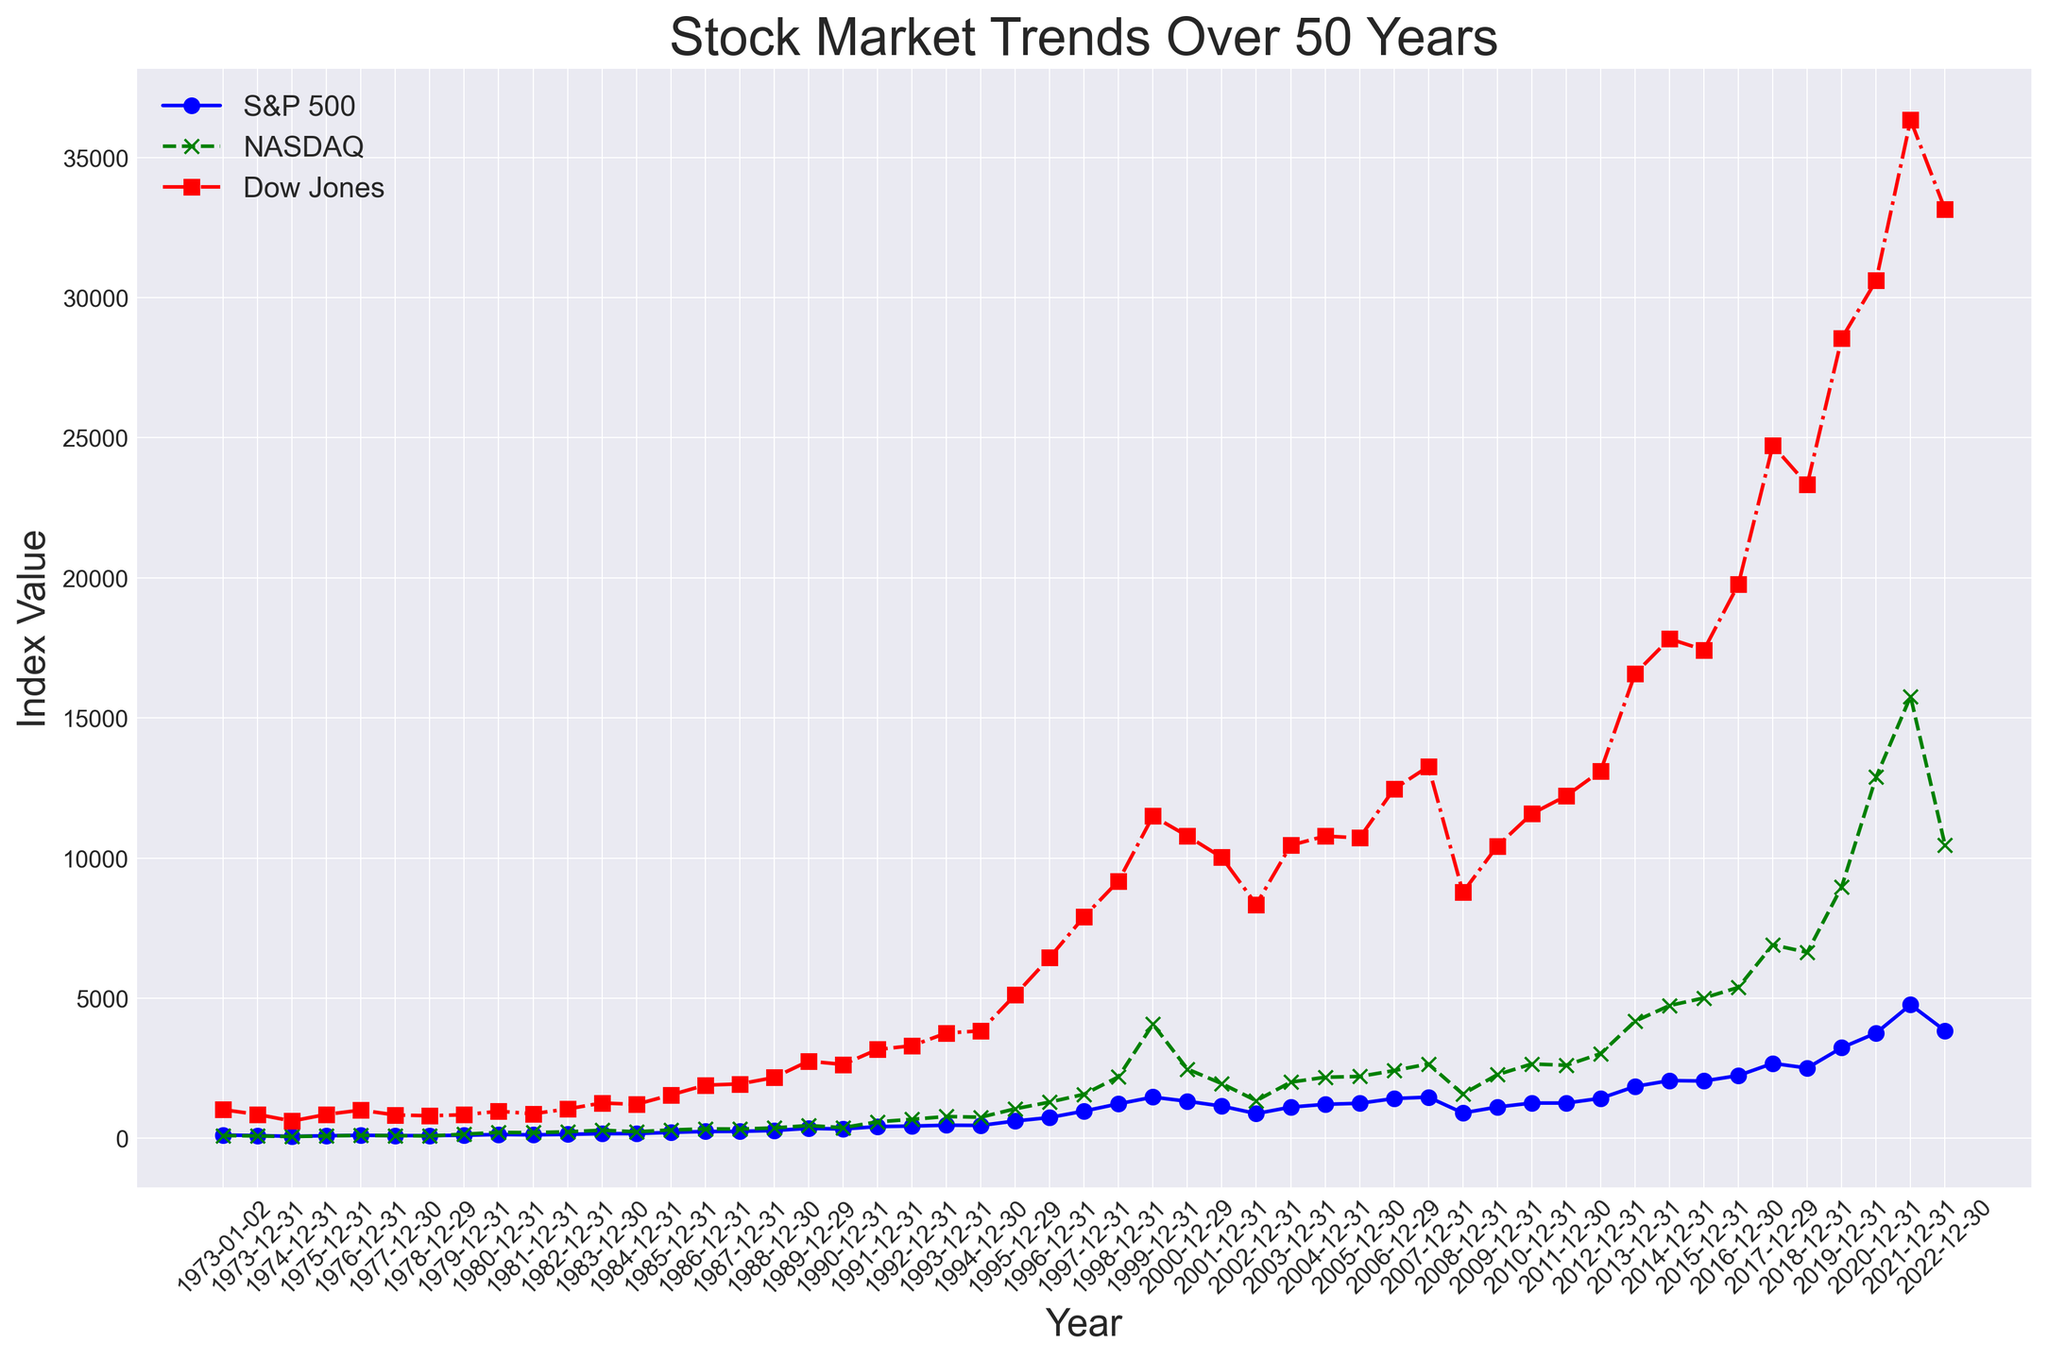What is the time period with the highest increase in the S&P 500 index? By observing the plot, the S&P 500 index shows the most significant increase between 2019 and 2022, when it jumps from approximately 3230 to 4766. This increase can be identified by looking at the steepness of the curve which represents rapid growth in this period.
Answer: 2019-2022 Which index had the highest value at the end of 2021? At the end of 2021, we compare the index values on the plot. The S&P 500 is approximately 4766, NASDAQ is around 15765, and Dow Jones is about 36338. Clearly, the Dow Jones had the highest value among the indices.
Answer: Dow Jones During which year did the NASDAQ index surpass 5000 for the first time? To determine this, we trace the NASDAQ line on the plot and see that it first crosses the 5000 mark towards the end of the year 2015. This can be identified by noting the crossing point of the NASDAQ plot over the 5000 value.
Answer: 2015 How did the Dow Jones index value at the end of 2008 compare to that at the end of 2007? On the plot, the Dow Jones line drops from around 13265 in 2007 to about 8776 in 2008. We observe a significant decrease noting the difference by tracing the trend line.
Answer: It decreased What are the minimum and maximum values of the S&P 500 index over the plotted period? By observing the plot, the minimum value of the S&P 500 index appears around 1974 with approximately 69 and the maximum value around 2021 with approximately 4766. These extremes are identified by noting the lowest and highest points on the S&P 500 line.
Answer: Minimum: ~69, Maximum: ~4766 In which year did the Dow Jones index first exceed 10,000? By tracing the Dow Jones trend line on the plot, we note that it first exceeds the 10,000 mark towards the end of 1999. This can be observed by the crossing point of the Dow Jones line over the 10,000 value mark.
Answer: 1999 Compare the trends of the three indices during the 2008 financial crisis. On the plot, we see a significant decline in all three indices from 2007 to 2008: S&P 500 drops from around 1468 to 903, NASDAQ drops from 2652 to 1577, and Dow Jones drops from 13265 to 8776. Visually, the sharp decline in the curves indicates a clear downturn during this period.
Answer: All decreased significantly How does the CAGR (Compound Annual Growth Rate) of the NASDAQ index from 2000 to 2020 compare to the S&P 500 in the same period? Using the CAGR formula: \(CAGR = \left(\frac{Ending\ Value}{Beginning\ Value}\right)^{\frac{1}{Years}} - 1\), we calculate for NASDAQ (2020: 12888, 2000: 2470): \(CAGR_{NASDAQ} = \left(\frac{12888}{2470}\right)^{\frac{1}{20}} - 1 \approx 0.083\ or\ 8.3%\) 
For S&P 500 (2020: 3756, 2000: 1320): \(CAGR_{S&P500} = \left(\frac{3756}{1320}\right)^{\frac{1}{20}} - 1 \approx 0.055\ or\ 5.5%\)
Thus, NASDAQ had a higher CAGR than S&P 500.
Answer: NASDAQ: ~8.3%, S&P500: ~5.5% 